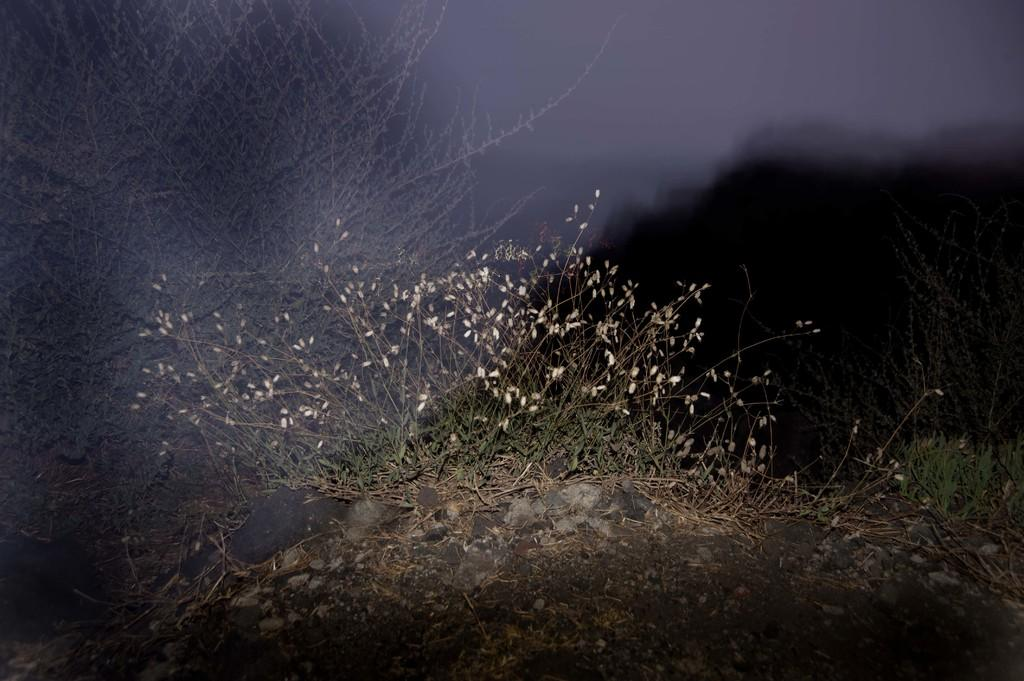What type of living organisms can be seen in the image? Plants can be seen in the image. What can be found on the ground in the image? There are stones on the ground in the image. How would you describe the background of the image? The background of the image is blurry and dark. What type of lace can be seen on the plants in the image? There is no lace present on the plants in the image; they are simply plants. 